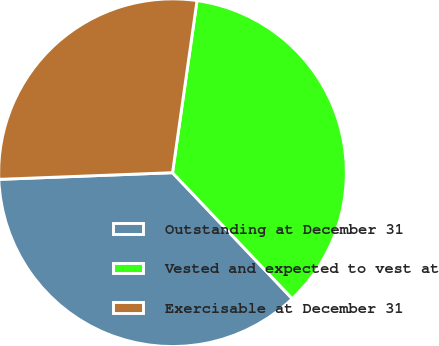Convert chart to OTSL. <chart><loc_0><loc_0><loc_500><loc_500><pie_chart><fcel>Outstanding at December 31<fcel>Vested and expected to vest at<fcel>Exercisable at December 31<nl><fcel>36.48%<fcel>35.66%<fcel>27.86%<nl></chart> 